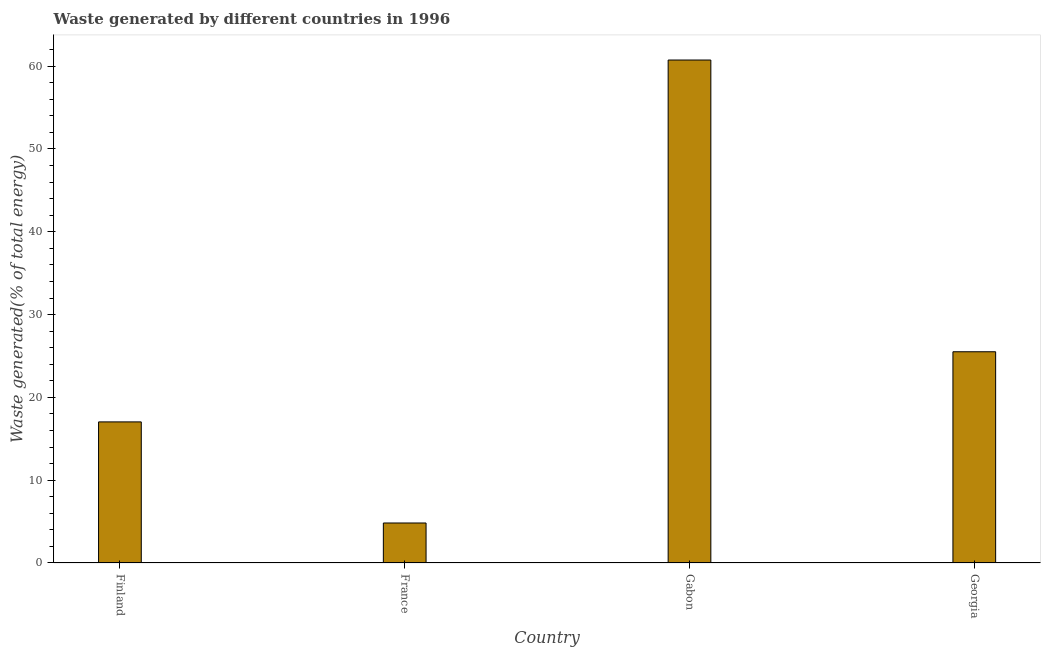Does the graph contain any zero values?
Your answer should be very brief. No. Does the graph contain grids?
Ensure brevity in your answer.  No. What is the title of the graph?
Make the answer very short. Waste generated by different countries in 1996. What is the label or title of the X-axis?
Make the answer very short. Country. What is the label or title of the Y-axis?
Keep it short and to the point. Waste generated(% of total energy). What is the amount of waste generated in Gabon?
Provide a succinct answer. 60.74. Across all countries, what is the maximum amount of waste generated?
Provide a succinct answer. 60.74. Across all countries, what is the minimum amount of waste generated?
Provide a succinct answer. 4.83. In which country was the amount of waste generated maximum?
Offer a very short reply. Gabon. What is the sum of the amount of waste generated?
Make the answer very short. 108.13. What is the difference between the amount of waste generated in Finland and Gabon?
Your response must be concise. -43.7. What is the average amount of waste generated per country?
Offer a terse response. 27.03. What is the median amount of waste generated?
Offer a very short reply. 21.28. In how many countries, is the amount of waste generated greater than 10 %?
Your answer should be compact. 3. What is the ratio of the amount of waste generated in Gabon to that in Georgia?
Ensure brevity in your answer.  2.38. What is the difference between the highest and the second highest amount of waste generated?
Your answer should be compact. 35.23. Is the sum of the amount of waste generated in France and Georgia greater than the maximum amount of waste generated across all countries?
Ensure brevity in your answer.  No. What is the difference between the highest and the lowest amount of waste generated?
Make the answer very short. 55.91. In how many countries, is the amount of waste generated greater than the average amount of waste generated taken over all countries?
Give a very brief answer. 1. Are all the bars in the graph horizontal?
Offer a very short reply. No. How many countries are there in the graph?
Your answer should be compact. 4. What is the difference between two consecutive major ticks on the Y-axis?
Offer a very short reply. 10. What is the Waste generated(% of total energy) in Finland?
Ensure brevity in your answer.  17.04. What is the Waste generated(% of total energy) of France?
Offer a very short reply. 4.83. What is the Waste generated(% of total energy) of Gabon?
Your response must be concise. 60.74. What is the Waste generated(% of total energy) of Georgia?
Provide a short and direct response. 25.51. What is the difference between the Waste generated(% of total energy) in Finland and France?
Your answer should be compact. 12.21. What is the difference between the Waste generated(% of total energy) in Finland and Gabon?
Give a very brief answer. -43.7. What is the difference between the Waste generated(% of total energy) in Finland and Georgia?
Your answer should be compact. -8.47. What is the difference between the Waste generated(% of total energy) in France and Gabon?
Your response must be concise. -55.91. What is the difference between the Waste generated(% of total energy) in France and Georgia?
Ensure brevity in your answer.  -20.68. What is the difference between the Waste generated(% of total energy) in Gabon and Georgia?
Offer a terse response. 35.23. What is the ratio of the Waste generated(% of total energy) in Finland to that in France?
Your answer should be compact. 3.53. What is the ratio of the Waste generated(% of total energy) in Finland to that in Gabon?
Offer a terse response. 0.28. What is the ratio of the Waste generated(% of total energy) in Finland to that in Georgia?
Offer a terse response. 0.67. What is the ratio of the Waste generated(% of total energy) in France to that in Gabon?
Provide a succinct answer. 0.08. What is the ratio of the Waste generated(% of total energy) in France to that in Georgia?
Offer a very short reply. 0.19. What is the ratio of the Waste generated(% of total energy) in Gabon to that in Georgia?
Give a very brief answer. 2.38. 